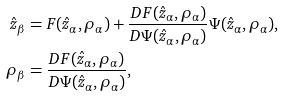Convert formula to latex. <formula><loc_0><loc_0><loc_500><loc_500>\hat { z } _ { \beta } & = F ( \hat { z } _ { \alpha } , \rho _ { \alpha } ) + \frac { D F ( \hat { z } _ { \alpha } , \rho _ { \alpha } ) } { D \Psi ( \hat { z } _ { \alpha } , \rho _ { \alpha } ) } \Psi ( \hat { z } _ { \alpha } , \rho _ { \alpha } ) , \\ \rho _ { \beta } & = \frac { D F ( \hat { z } _ { \alpha } , \rho _ { \alpha } ) } { D \Psi ( \hat { z } _ { \alpha } , \rho _ { \alpha } ) } ,</formula> 